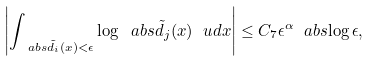Convert formula to latex. <formula><loc_0><loc_0><loc_500><loc_500>\left | \int _ { \ a b s { \tilde { d } _ { i } ( x ) } < \epsilon } \log \ a b s { \tilde { d } _ { j } ( x ) } \ u d x \right | \leq C _ { 7 } \epsilon ^ { \alpha } \ a b s { \log \epsilon } ,</formula> 